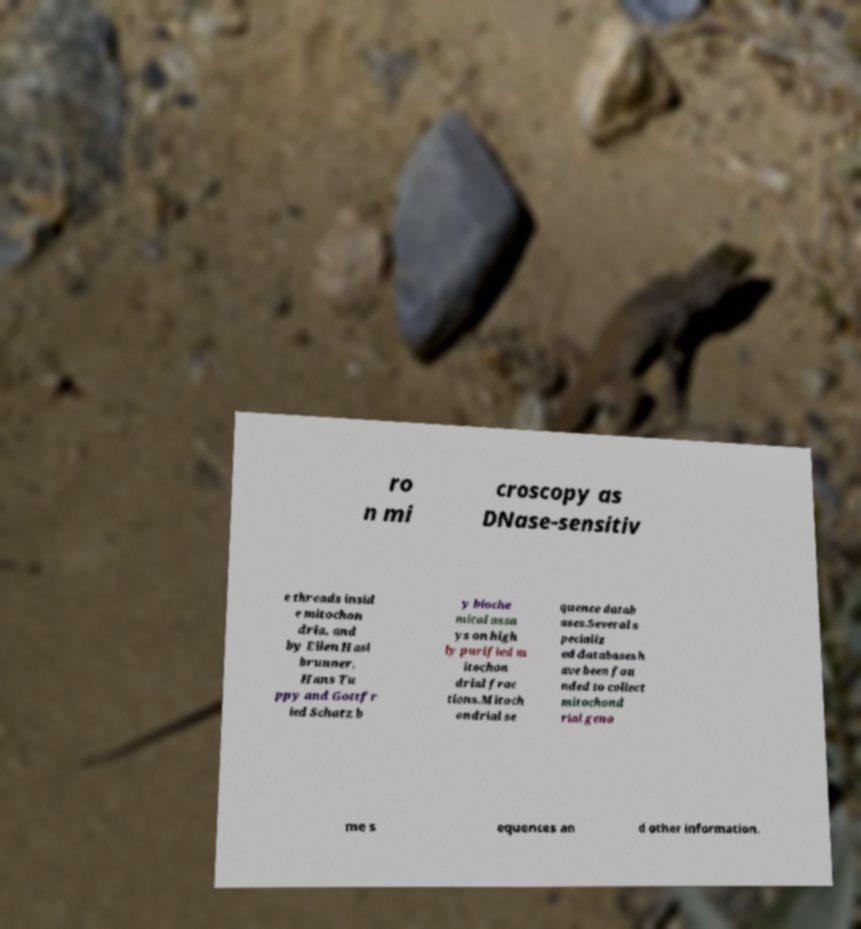Please read and relay the text visible in this image. What does it say? ro n mi croscopy as DNase-sensitiv e threads insid e mitochon dria, and by Ellen Hasl brunner, Hans Tu ppy and Gottfr ied Schatz b y bioche mical assa ys on high ly purified m itochon drial frac tions.Mitoch ondrial se quence datab ases.Several s pecializ ed databases h ave been fou nded to collect mitochond rial geno me s equences an d other information. 